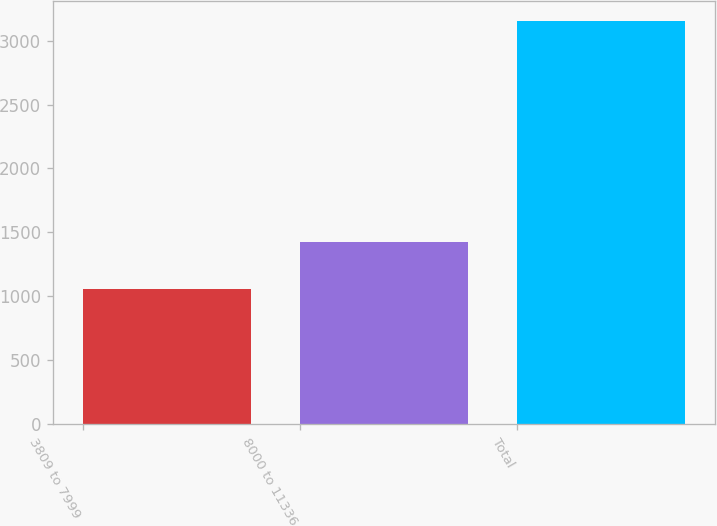Convert chart to OTSL. <chart><loc_0><loc_0><loc_500><loc_500><bar_chart><fcel>3809 to 7999<fcel>8000 to 11336<fcel>Total<nl><fcel>1059<fcel>1423<fcel>3154<nl></chart> 